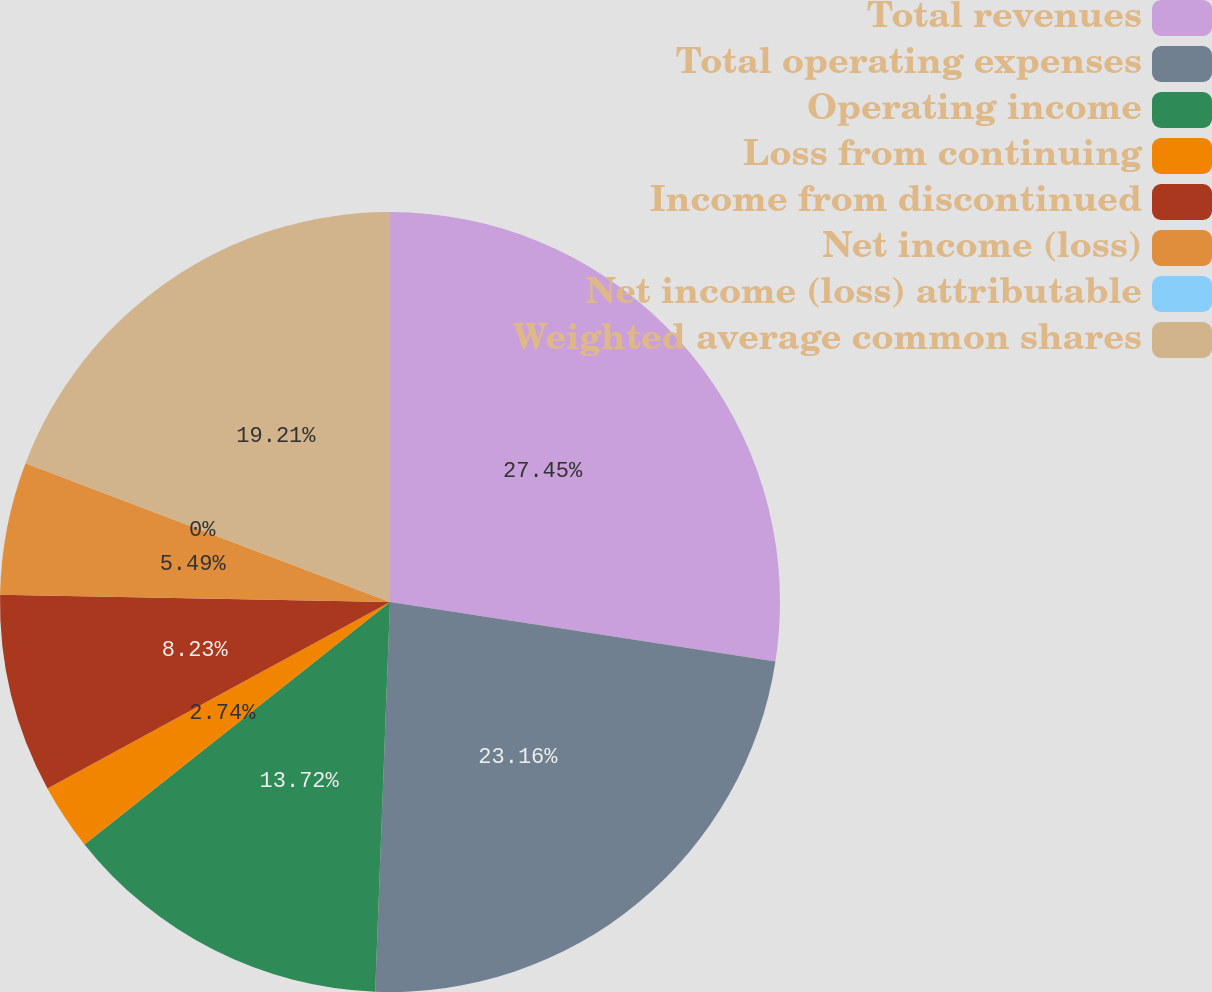<chart> <loc_0><loc_0><loc_500><loc_500><pie_chart><fcel>Total revenues<fcel>Total operating expenses<fcel>Operating income<fcel>Loss from continuing<fcel>Income from discontinued<fcel>Net income (loss)<fcel>Net income (loss) attributable<fcel>Weighted average common shares<nl><fcel>27.44%<fcel>23.16%<fcel>13.72%<fcel>2.74%<fcel>8.23%<fcel>5.49%<fcel>0.0%<fcel>19.21%<nl></chart> 